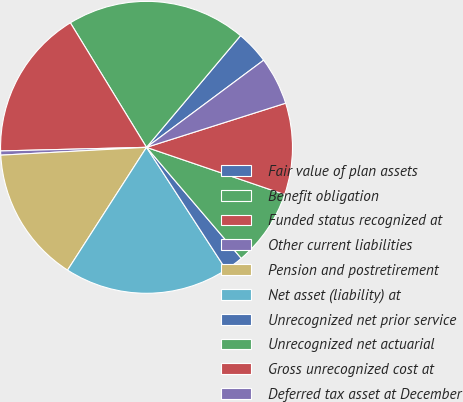<chart> <loc_0><loc_0><loc_500><loc_500><pie_chart><fcel>Fair value of plan assets<fcel>Benefit obligation<fcel>Funded status recognized at<fcel>Other current liabilities<fcel>Pension and postretirement<fcel>Net asset (liability) at<fcel>Unrecognized net prior service<fcel>Unrecognized net actuarial<fcel>Gross unrecognized cost at<fcel>Deferred tax asset at December<nl><fcel>3.68%<fcel>19.88%<fcel>16.66%<fcel>0.46%<fcel>15.05%<fcel>18.27%<fcel>2.07%<fcel>8.52%<fcel>10.13%<fcel>5.29%<nl></chart> 